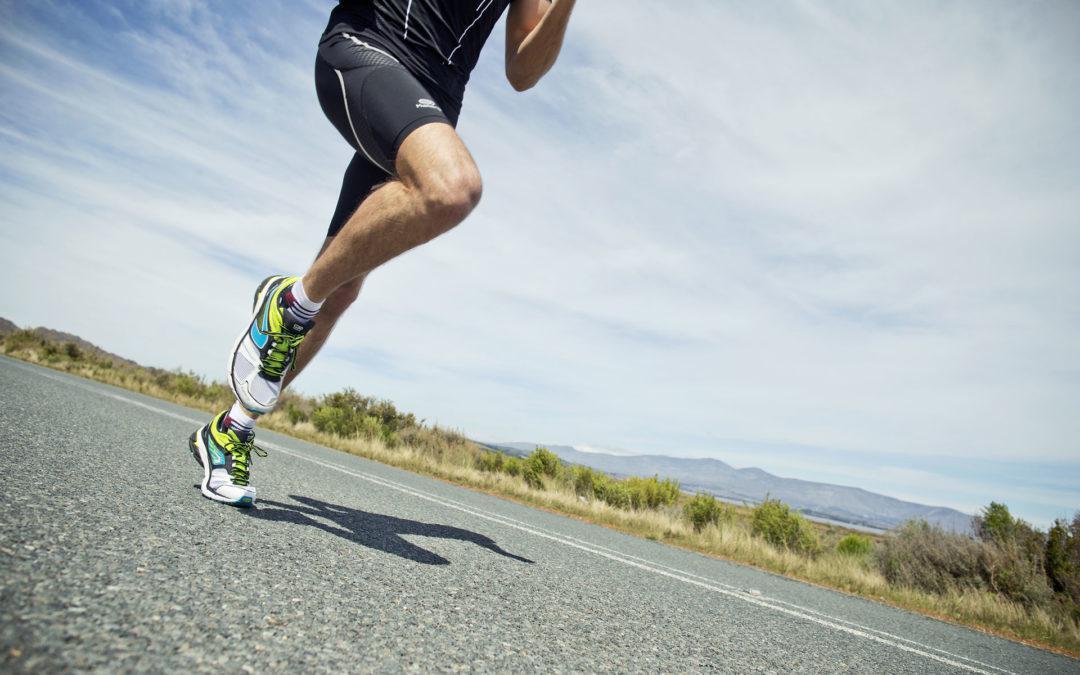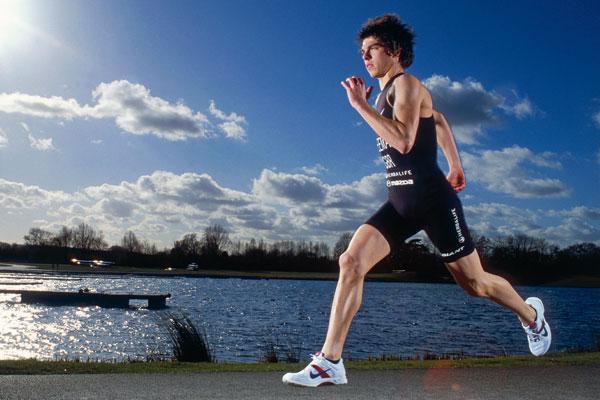The first image is the image on the left, the second image is the image on the right. Examine the images to the left and right. Is the description "One person is running leftward in front of a body of water." accurate? Answer yes or no. Yes. The first image is the image on the left, the second image is the image on the right. Analyze the images presented: Is the assertion "One of the runners is running on a road and the other is running by a body of water." valid? Answer yes or no. Yes. 